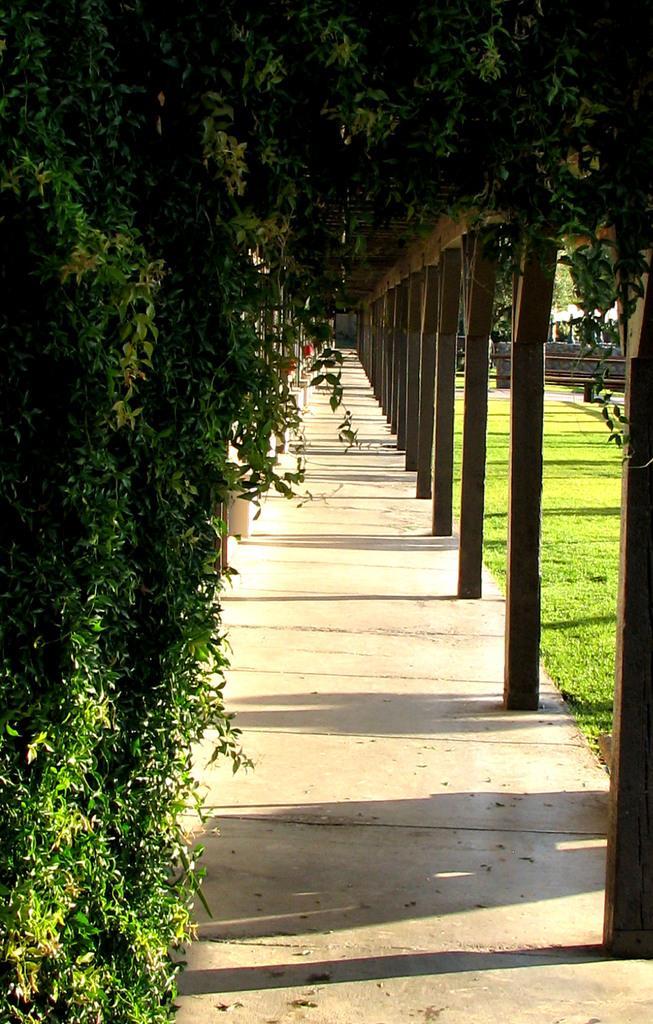In one or two sentences, can you explain what this image depicts? In the picture we can see a pathway and beside it, we can see poles, which are attached to the roof and to the wall we can see plants and beside the path we can see grass surface. 